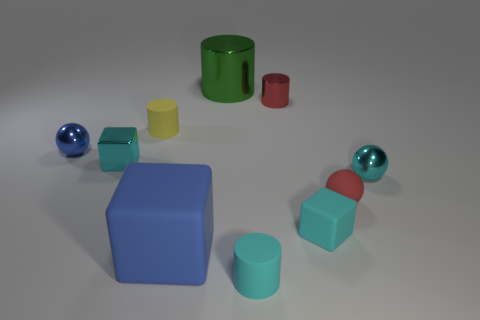There is a cyan thing that is both behind the big rubber block and left of the small red metallic thing; what material is it?
Keep it short and to the point. Metal. Is the number of red matte objects less than the number of big things?
Make the answer very short. Yes. Is the shape of the yellow matte object the same as the large thing behind the cyan metal block?
Your response must be concise. Yes. Is the size of the blue object that is in front of the blue sphere the same as the big green metallic cylinder?
Give a very brief answer. Yes. There is a red shiny object that is the same size as the cyan matte cylinder; what is its shape?
Offer a very short reply. Cylinder. Do the large green thing and the tiny yellow rubber thing have the same shape?
Offer a very short reply. Yes. How many large blue rubber objects are the same shape as the blue metal object?
Keep it short and to the point. 0. There is a yellow cylinder; how many tiny metallic things are in front of it?
Ensure brevity in your answer.  3. There is a tiny block that is right of the tiny red shiny thing; is its color the same as the metallic block?
Your answer should be compact. Yes. How many matte balls are the same size as the blue shiny thing?
Your answer should be very brief. 1. 